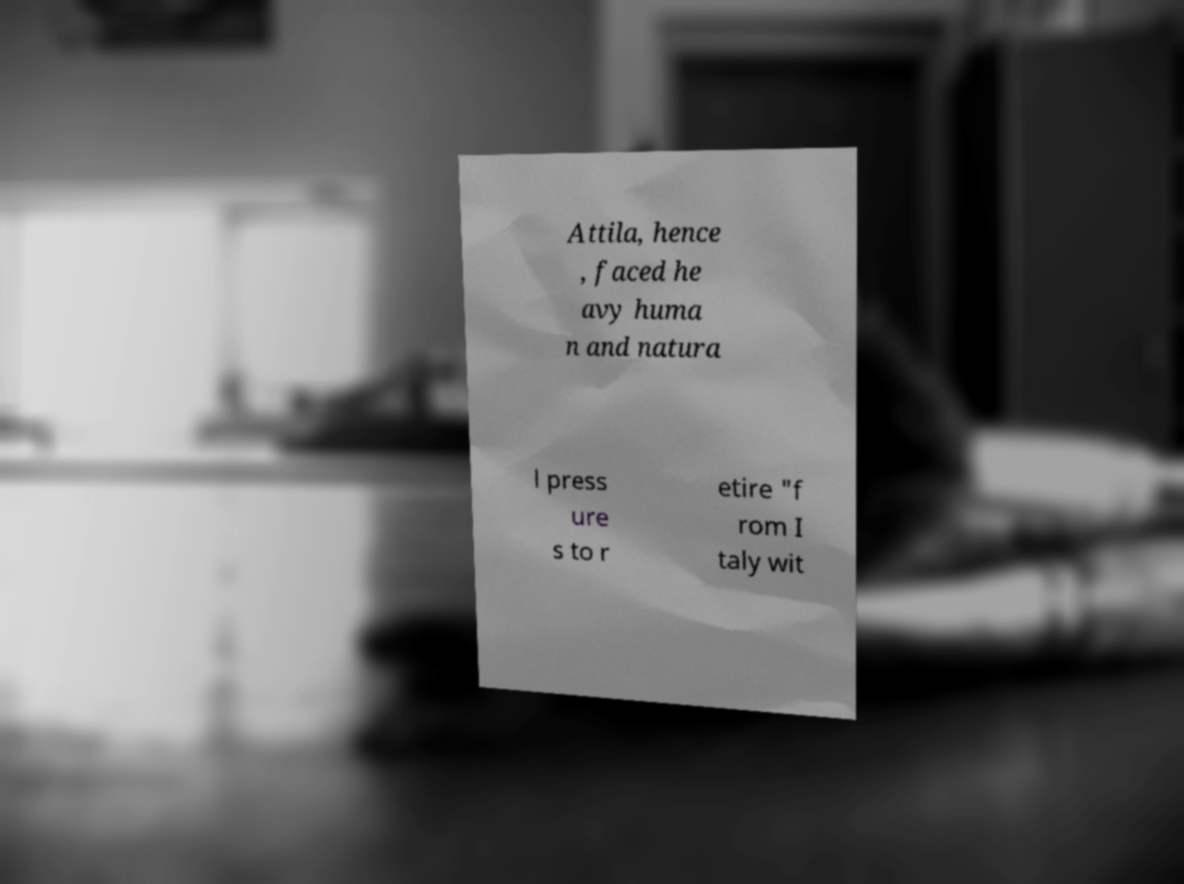There's text embedded in this image that I need extracted. Can you transcribe it verbatim? Attila, hence , faced he avy huma n and natura l press ure s to r etire "f rom I taly wit 